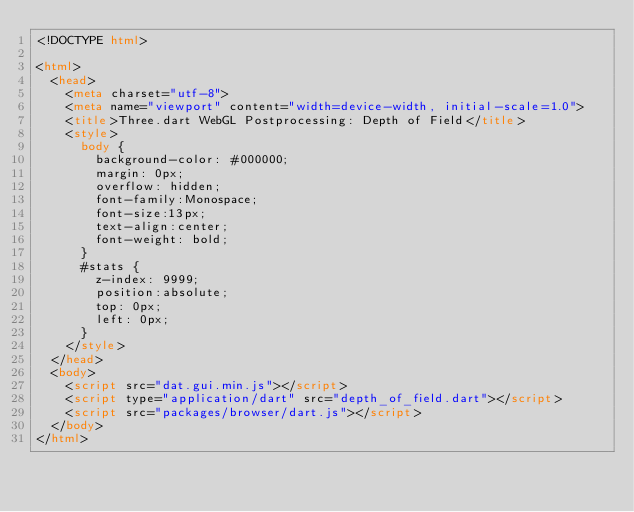<code> <loc_0><loc_0><loc_500><loc_500><_HTML_><!DOCTYPE html>

<html>
  <head>
  	<meta charset="utf-8">
  	<meta name="viewport" content="width=device-width, initial-scale=1.0">
    <title>Three.dart WebGL Postprocessing: Depth of Field</title>
    <style>
      body {
        background-color: #000000;
        margin: 0px;
        overflow: hidden;
        font-family:Monospace;
        font-size:13px;
        text-align:center;
        font-weight: bold;
      }
      #stats {
        z-index: 9999;
        position:absolute;
        top: 0px;
        left: 0px;
      }
    </style>
  </head>
  <body>
    <script src="dat.gui.min.js"></script>
    <script type="application/dart" src="depth_of_field.dart"></script>
    <script src="packages/browser/dart.js"></script>
  </body>
</html>
</code> 